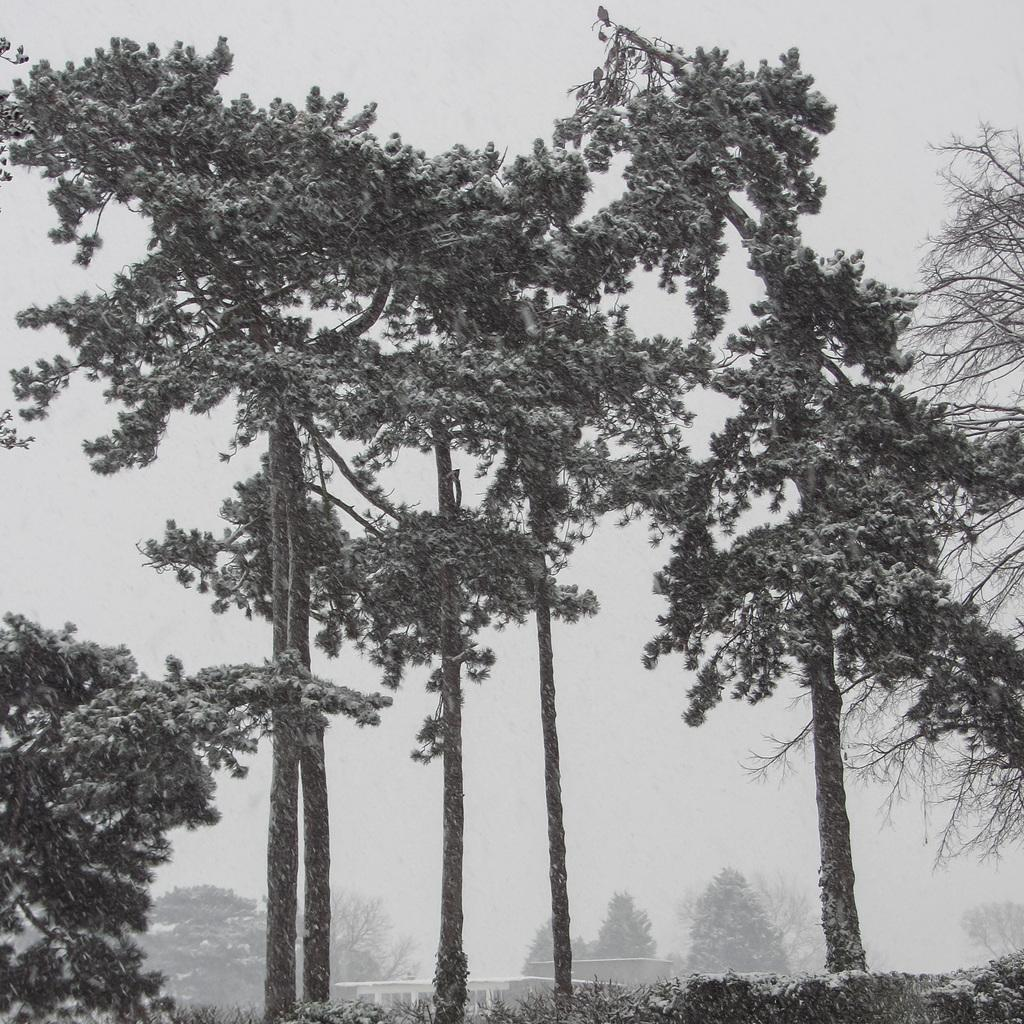What type of vegetation can be seen in the image? There are plants and trees in the image. How can you tell that it is winter in the image? Snow is visible on the trees, which indicates a winter season. What type of question is being asked in the image? There is no question being asked in the image; it is a visual representation of plants, trees, and snow. Can you see a ship in the image? No, there is no ship present in the image. 